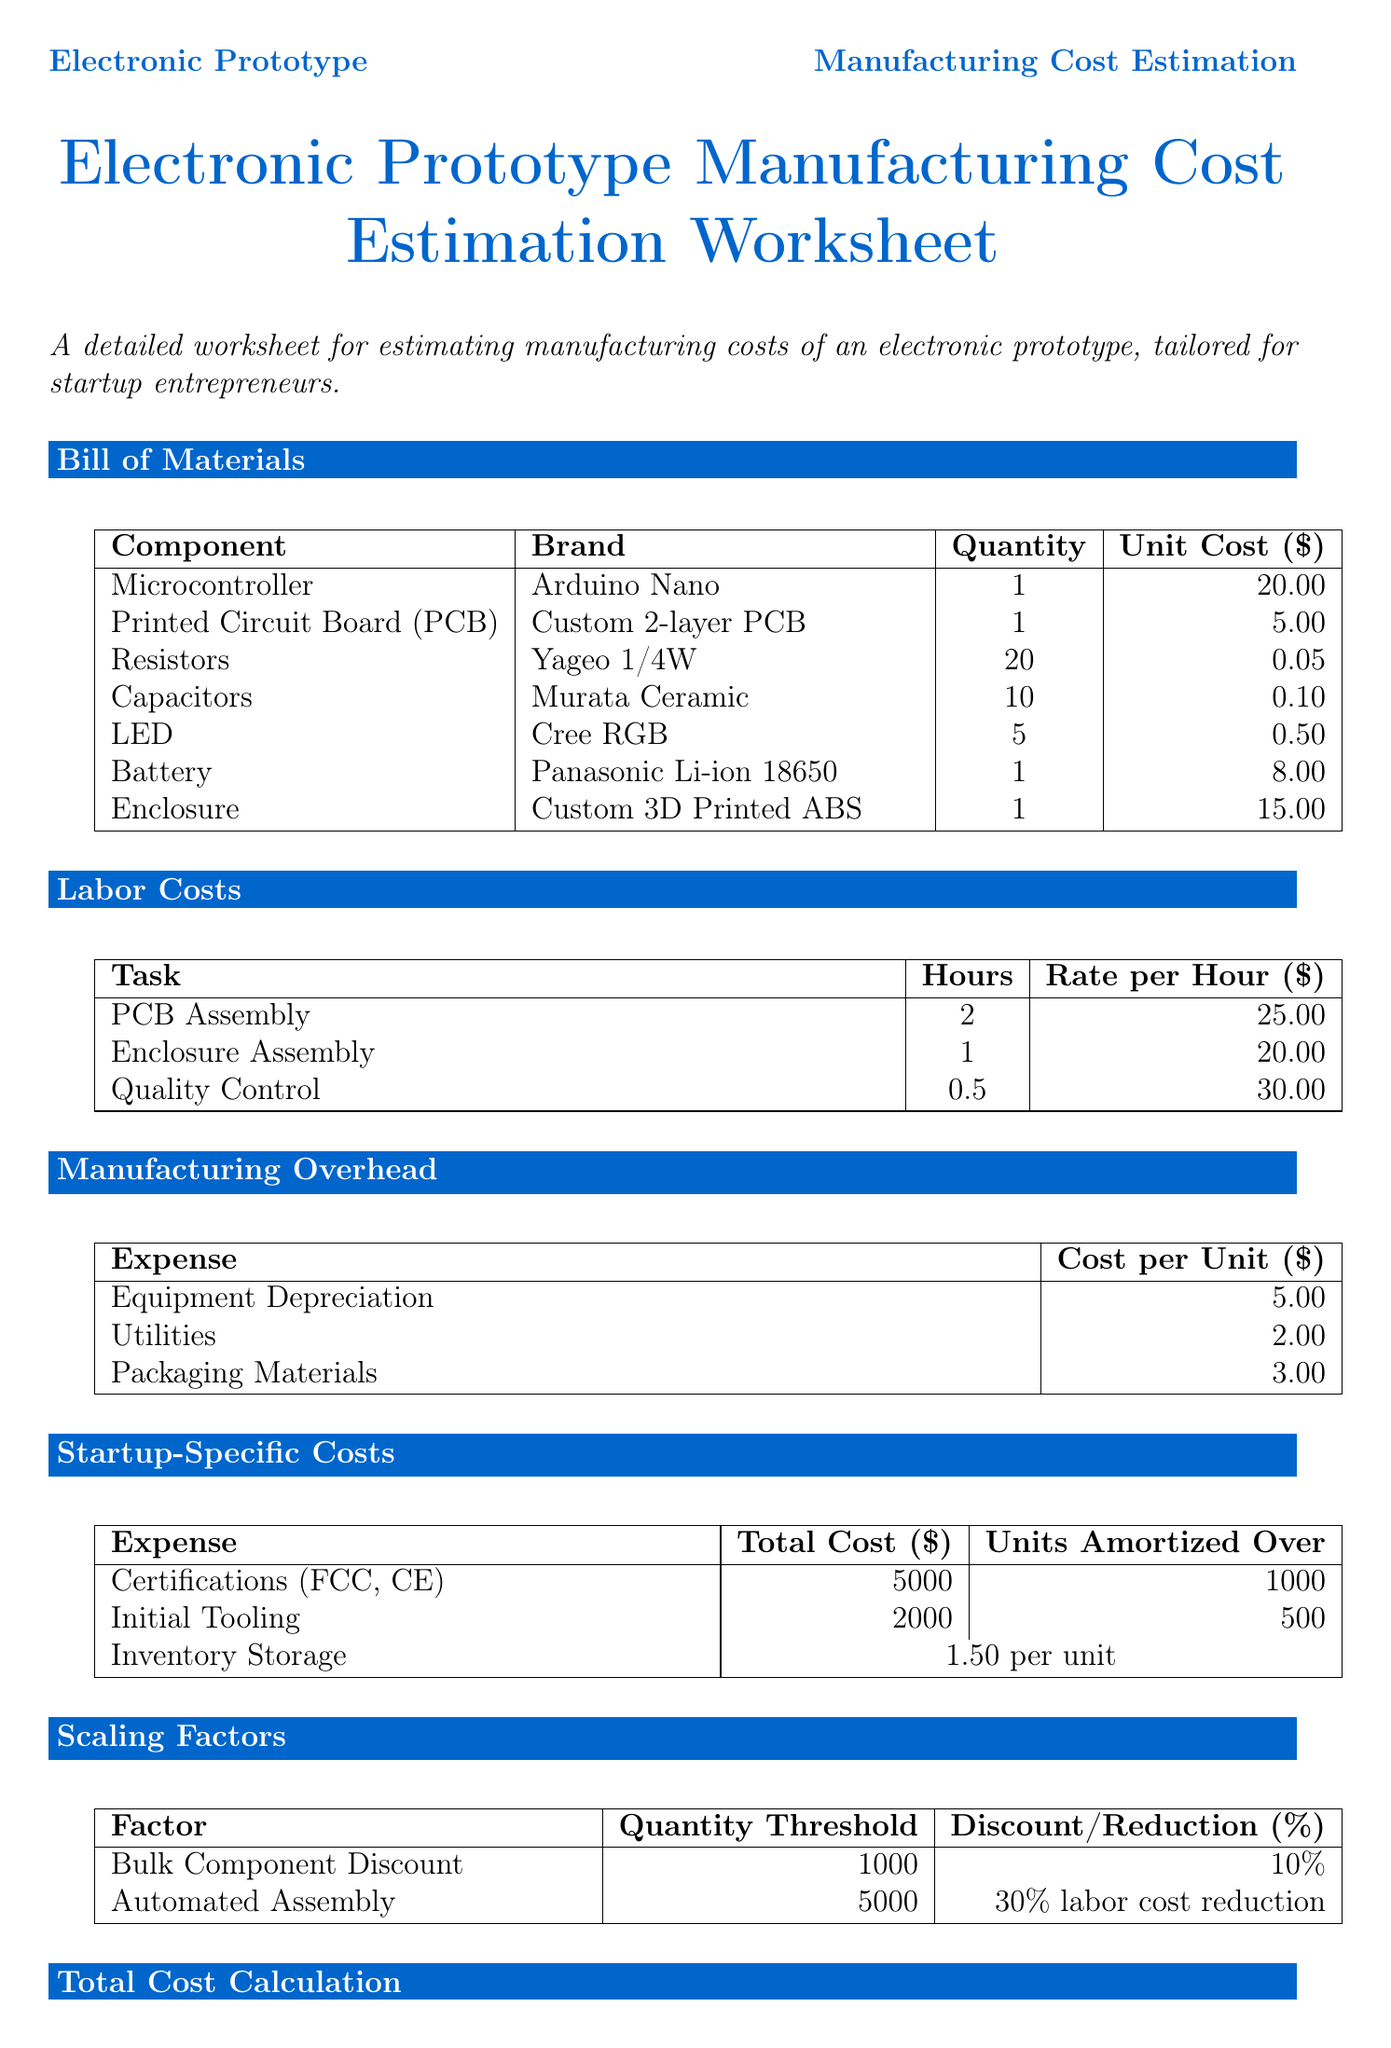What is the total cost of the Microcontroller? The unit cost of the Microcontroller is $20.00 and the quantity is 1.
Answer: $20.00 How many Capacitors are listed in the Bill of Materials? The number of Capacitors in the Bill of Materials is 10.
Answer: 10 What is the labor cost for Quality Control per hour? The rate per hour for Quality Control is $30.00.
Answer: $30.00 What is the suggested profit margin for 1-100 units? The suggested margin for 1-100 units is 40 percent.
Answer: 40 percent How much does Packaging Materials cost per unit? The cost per unit for Packaging Materials is $3.00.
Answer: $3.00 What is the total cost for Certifications (FCC, CE)? The total cost for Certifications (FCC, CE) is $5000.
Answer: $5000 At what quantity threshold does the Bulk Component Discount apply? The quantity threshold for the Bulk Component Discount is 1000 units.
Answer: 1000 units What is the total cost of the Battery? The unit cost of the Battery is $8.00 and the quantity is 1.
Answer: $8.00 What is the formula used for total cost calculation? The total cost calculation formula is the sum of Bill of Materials, Labor Costs, Manufacturing Overhead, and Startup-Specific Costs.
Answer: Sum of Bill of Materials, Labor Costs, Manufacturing Overhead, and Startup-Specific Costs 